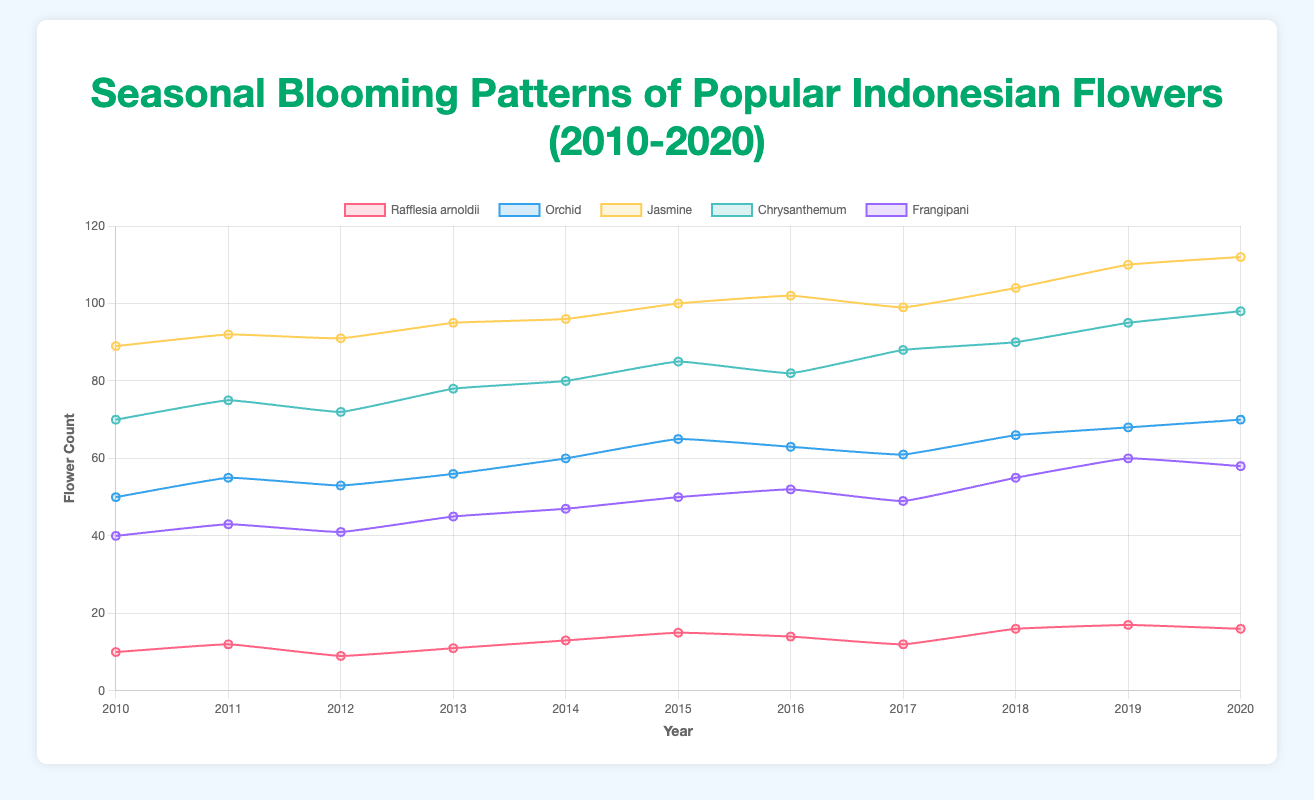What is the average number of blooming Jasmine flowers between 2010 and 2020? First, sum up all the flower counts for Jasmine from 2010 to 2020: 89 + 92 + 91 + 95 + 96 + 100 + 102 + 99 + 104 + 110 + 112 = 1090. Divide this by the number of years (11). 1090 / 11 ≈ 99.09
Answer: 99.09 Which year had the highest blooming count for Orchids, and what was the count? By looking at the dataset for Orchids, the highest flower count is observed in 2020 with 70 flowers.
Answer: 2020, 70 Between Rafflesia arnoldii and Frangipani, which flower had more blooms in 2015? For Rafflesia arnoldii in 2015, the flower count is 15. For Frangipani in 2015, the flower count is 50. Frangipani had more blooms.
Answer: Frangipani How does the trend in the flower count for Chrysanthemum change from 2010 to 2020? Starting from 2010, the count goes 70, 75, 72, 78, 80, 85, 82, 88, 90, 95, 98 which suggests an overall increasing trend with minor fluctuations in certain years.
Answer: Increasing trend What is the difference in blooming flower counts for Frangipani between the maximum and minimum values observed? The maximum count for Frangipani is 60 in 2019 and the minimum is 40 in 2010. The difference is 60 - 40 = 20.
Answer: 20 Which flower shows the steepest increase in its blooming pattern between any two consecutive years, and what is the value of that increase? Looking at the datasets, Jasmine shows a significant increase from 2018 to 2019: from 104 to 110, an increase of 6 flowers.
Answer: Jasmine, 6 During which season does Rafflesia arnoldii bloom the most often based on the data? All the data points for Rafflesia arnoldii indicate it blooms during the Summer season.
Answer: Summer Compare the blooming patterns of Jasmine and Orchids. Which one consistently had higher blooming counts from 2010 to 2020? For the entire period, Jasmine had higher blooming counts consistently as it never drops below 89 whereas Orchid's count ranged from 50 to 70.
Answer: Jasmine 